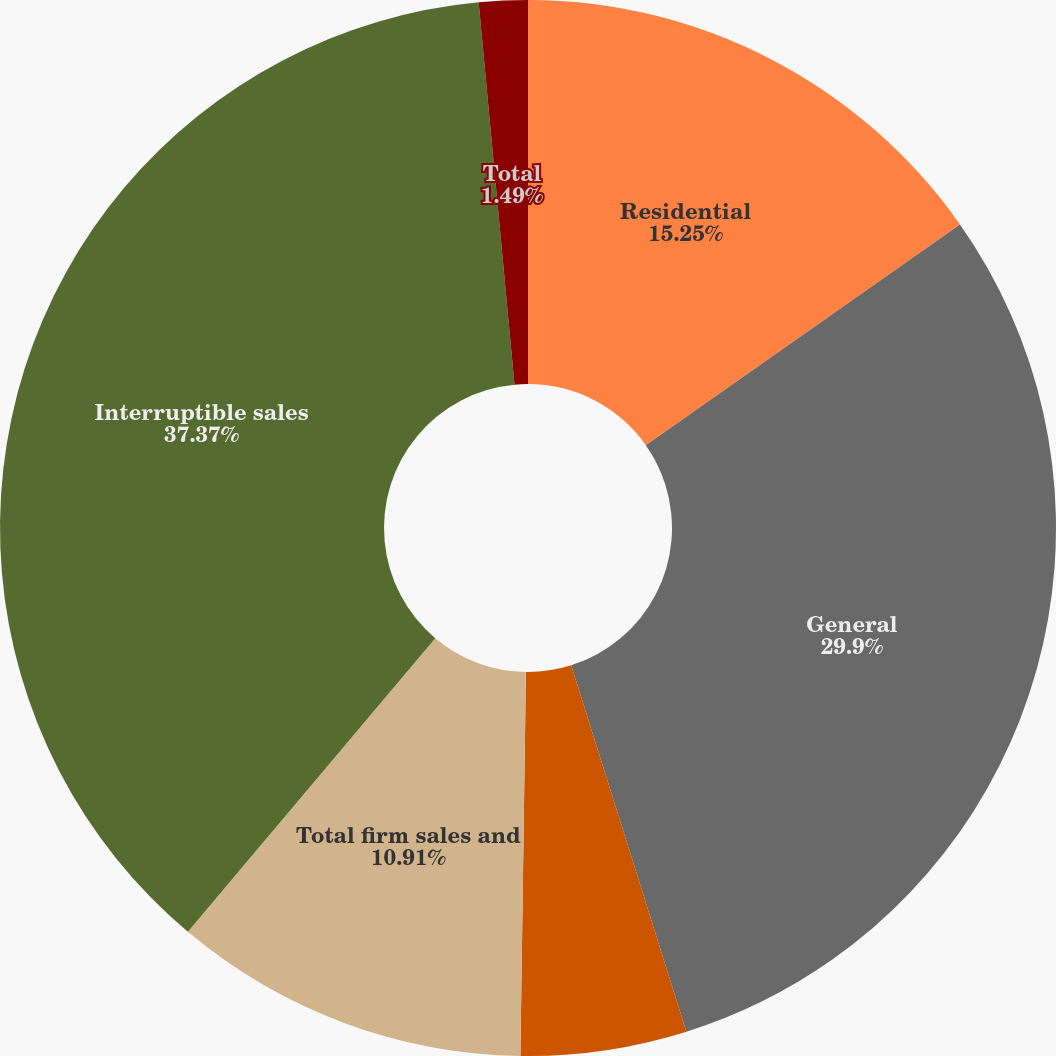Convert chart. <chart><loc_0><loc_0><loc_500><loc_500><pie_chart><fcel>Residential<fcel>General<fcel>Firm transportation<fcel>Total firm sales and<fcel>Interruptible sales<fcel>Total<nl><fcel>15.25%<fcel>29.9%<fcel>5.08%<fcel>10.91%<fcel>37.37%<fcel>1.49%<nl></chart> 